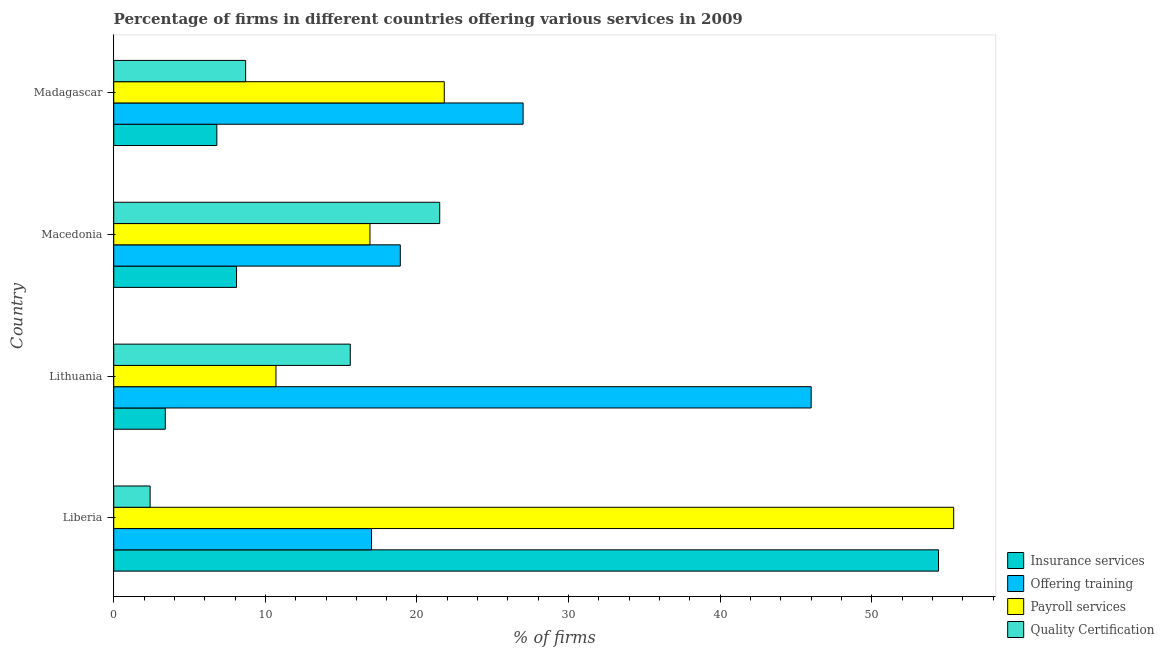How many different coloured bars are there?
Offer a very short reply. 4. How many bars are there on the 3rd tick from the top?
Offer a very short reply. 4. What is the label of the 1st group of bars from the top?
Ensure brevity in your answer.  Madagascar. In how many cases, is the number of bars for a given country not equal to the number of legend labels?
Make the answer very short. 0. Across all countries, what is the maximum percentage of firms offering payroll services?
Provide a succinct answer. 55.4. In which country was the percentage of firms offering payroll services maximum?
Ensure brevity in your answer.  Liberia. In which country was the percentage of firms offering insurance services minimum?
Provide a short and direct response. Lithuania. What is the total percentage of firms offering payroll services in the graph?
Your response must be concise. 104.8. What is the difference between the percentage of firms offering payroll services in Madagascar and the percentage of firms offering quality certification in Macedonia?
Ensure brevity in your answer.  0.3. What is the average percentage of firms offering insurance services per country?
Your answer should be very brief. 18.18. What is the difference between the percentage of firms offering payroll services and percentage of firms offering training in Liberia?
Offer a terse response. 38.4. What is the ratio of the percentage of firms offering payroll services in Liberia to that in Macedonia?
Your answer should be compact. 3.28. Is the difference between the percentage of firms offering quality certification in Macedonia and Madagascar greater than the difference between the percentage of firms offering payroll services in Macedonia and Madagascar?
Your response must be concise. Yes. What is the difference between the highest and the second highest percentage of firms offering payroll services?
Offer a terse response. 33.6. What is the difference between the highest and the lowest percentage of firms offering training?
Offer a terse response. 29. In how many countries, is the percentage of firms offering payroll services greater than the average percentage of firms offering payroll services taken over all countries?
Ensure brevity in your answer.  1. Is it the case that in every country, the sum of the percentage of firms offering insurance services and percentage of firms offering payroll services is greater than the sum of percentage of firms offering training and percentage of firms offering quality certification?
Provide a short and direct response. No. What does the 1st bar from the top in Macedonia represents?
Your response must be concise. Quality Certification. What does the 3rd bar from the bottom in Madagascar represents?
Your response must be concise. Payroll services. Are all the bars in the graph horizontal?
Provide a succinct answer. Yes. What is the difference between two consecutive major ticks on the X-axis?
Provide a succinct answer. 10. Are the values on the major ticks of X-axis written in scientific E-notation?
Your answer should be very brief. No. Where does the legend appear in the graph?
Your response must be concise. Bottom right. How are the legend labels stacked?
Provide a short and direct response. Vertical. What is the title of the graph?
Offer a terse response. Percentage of firms in different countries offering various services in 2009. What is the label or title of the X-axis?
Provide a succinct answer. % of firms. What is the % of firms in Insurance services in Liberia?
Your answer should be very brief. 54.4. What is the % of firms in Payroll services in Liberia?
Provide a short and direct response. 55.4. What is the % of firms of Offering training in Lithuania?
Ensure brevity in your answer.  46. What is the % of firms of Quality Certification in Lithuania?
Your answer should be very brief. 15.6. What is the % of firms of Offering training in Macedonia?
Your answer should be compact. 18.9. What is the % of firms of Payroll services in Macedonia?
Your answer should be very brief. 16.9. What is the % of firms in Quality Certification in Macedonia?
Your answer should be compact. 21.5. What is the % of firms in Insurance services in Madagascar?
Ensure brevity in your answer.  6.8. What is the % of firms in Payroll services in Madagascar?
Provide a succinct answer. 21.8. Across all countries, what is the maximum % of firms of Insurance services?
Give a very brief answer. 54.4. Across all countries, what is the maximum % of firms in Payroll services?
Provide a succinct answer. 55.4. Across all countries, what is the maximum % of firms of Quality Certification?
Your response must be concise. 21.5. Across all countries, what is the minimum % of firms of Offering training?
Your response must be concise. 17. What is the total % of firms in Insurance services in the graph?
Make the answer very short. 72.7. What is the total % of firms in Offering training in the graph?
Your response must be concise. 108.9. What is the total % of firms in Payroll services in the graph?
Offer a terse response. 104.8. What is the total % of firms in Quality Certification in the graph?
Keep it short and to the point. 48.2. What is the difference between the % of firms in Insurance services in Liberia and that in Lithuania?
Give a very brief answer. 51. What is the difference between the % of firms of Payroll services in Liberia and that in Lithuania?
Provide a short and direct response. 44.7. What is the difference between the % of firms of Insurance services in Liberia and that in Macedonia?
Ensure brevity in your answer.  46.3. What is the difference between the % of firms in Payroll services in Liberia and that in Macedonia?
Offer a terse response. 38.5. What is the difference between the % of firms in Quality Certification in Liberia and that in Macedonia?
Keep it short and to the point. -19.1. What is the difference between the % of firms of Insurance services in Liberia and that in Madagascar?
Your answer should be very brief. 47.6. What is the difference between the % of firms of Offering training in Liberia and that in Madagascar?
Keep it short and to the point. -10. What is the difference between the % of firms of Payroll services in Liberia and that in Madagascar?
Your answer should be compact. 33.6. What is the difference between the % of firms of Insurance services in Lithuania and that in Macedonia?
Provide a succinct answer. -4.7. What is the difference between the % of firms in Offering training in Lithuania and that in Macedonia?
Give a very brief answer. 27.1. What is the difference between the % of firms of Payroll services in Lithuania and that in Macedonia?
Offer a terse response. -6.2. What is the difference between the % of firms of Insurance services in Lithuania and that in Madagascar?
Give a very brief answer. -3.4. What is the difference between the % of firms in Offering training in Lithuania and that in Madagascar?
Your response must be concise. 19. What is the difference between the % of firms of Insurance services in Macedonia and that in Madagascar?
Your answer should be very brief. 1.3. What is the difference between the % of firms in Offering training in Macedonia and that in Madagascar?
Keep it short and to the point. -8.1. What is the difference between the % of firms of Payroll services in Macedonia and that in Madagascar?
Your response must be concise. -4.9. What is the difference between the % of firms of Insurance services in Liberia and the % of firms of Offering training in Lithuania?
Keep it short and to the point. 8.4. What is the difference between the % of firms of Insurance services in Liberia and the % of firms of Payroll services in Lithuania?
Your response must be concise. 43.7. What is the difference between the % of firms in Insurance services in Liberia and the % of firms in Quality Certification in Lithuania?
Your answer should be very brief. 38.8. What is the difference between the % of firms of Offering training in Liberia and the % of firms of Payroll services in Lithuania?
Offer a very short reply. 6.3. What is the difference between the % of firms in Offering training in Liberia and the % of firms in Quality Certification in Lithuania?
Give a very brief answer. 1.4. What is the difference between the % of firms in Payroll services in Liberia and the % of firms in Quality Certification in Lithuania?
Provide a short and direct response. 39.8. What is the difference between the % of firms of Insurance services in Liberia and the % of firms of Offering training in Macedonia?
Keep it short and to the point. 35.5. What is the difference between the % of firms in Insurance services in Liberia and the % of firms in Payroll services in Macedonia?
Offer a very short reply. 37.5. What is the difference between the % of firms of Insurance services in Liberia and the % of firms of Quality Certification in Macedonia?
Offer a very short reply. 32.9. What is the difference between the % of firms in Offering training in Liberia and the % of firms in Payroll services in Macedonia?
Your answer should be very brief. 0.1. What is the difference between the % of firms of Offering training in Liberia and the % of firms of Quality Certification in Macedonia?
Your answer should be compact. -4.5. What is the difference between the % of firms of Payroll services in Liberia and the % of firms of Quality Certification in Macedonia?
Ensure brevity in your answer.  33.9. What is the difference between the % of firms of Insurance services in Liberia and the % of firms of Offering training in Madagascar?
Your answer should be very brief. 27.4. What is the difference between the % of firms in Insurance services in Liberia and the % of firms in Payroll services in Madagascar?
Give a very brief answer. 32.6. What is the difference between the % of firms in Insurance services in Liberia and the % of firms in Quality Certification in Madagascar?
Your answer should be very brief. 45.7. What is the difference between the % of firms of Offering training in Liberia and the % of firms of Quality Certification in Madagascar?
Provide a short and direct response. 8.3. What is the difference between the % of firms in Payroll services in Liberia and the % of firms in Quality Certification in Madagascar?
Offer a terse response. 46.7. What is the difference between the % of firms in Insurance services in Lithuania and the % of firms in Offering training in Macedonia?
Offer a very short reply. -15.5. What is the difference between the % of firms in Insurance services in Lithuania and the % of firms in Payroll services in Macedonia?
Your answer should be compact. -13.5. What is the difference between the % of firms of Insurance services in Lithuania and the % of firms of Quality Certification in Macedonia?
Provide a short and direct response. -18.1. What is the difference between the % of firms of Offering training in Lithuania and the % of firms of Payroll services in Macedonia?
Give a very brief answer. 29.1. What is the difference between the % of firms in Offering training in Lithuania and the % of firms in Quality Certification in Macedonia?
Ensure brevity in your answer.  24.5. What is the difference between the % of firms of Payroll services in Lithuania and the % of firms of Quality Certification in Macedonia?
Your response must be concise. -10.8. What is the difference between the % of firms in Insurance services in Lithuania and the % of firms in Offering training in Madagascar?
Give a very brief answer. -23.6. What is the difference between the % of firms in Insurance services in Lithuania and the % of firms in Payroll services in Madagascar?
Provide a short and direct response. -18.4. What is the difference between the % of firms of Offering training in Lithuania and the % of firms of Payroll services in Madagascar?
Offer a terse response. 24.2. What is the difference between the % of firms in Offering training in Lithuania and the % of firms in Quality Certification in Madagascar?
Offer a very short reply. 37.3. What is the difference between the % of firms of Insurance services in Macedonia and the % of firms of Offering training in Madagascar?
Ensure brevity in your answer.  -18.9. What is the difference between the % of firms in Insurance services in Macedonia and the % of firms in Payroll services in Madagascar?
Your answer should be compact. -13.7. What is the difference between the % of firms of Insurance services in Macedonia and the % of firms of Quality Certification in Madagascar?
Make the answer very short. -0.6. What is the difference between the % of firms of Offering training in Macedonia and the % of firms of Payroll services in Madagascar?
Your answer should be compact. -2.9. What is the difference between the % of firms of Payroll services in Macedonia and the % of firms of Quality Certification in Madagascar?
Give a very brief answer. 8.2. What is the average % of firms in Insurance services per country?
Offer a terse response. 18.18. What is the average % of firms of Offering training per country?
Your answer should be compact. 27.23. What is the average % of firms of Payroll services per country?
Your answer should be very brief. 26.2. What is the average % of firms of Quality Certification per country?
Ensure brevity in your answer.  12.05. What is the difference between the % of firms of Insurance services and % of firms of Offering training in Liberia?
Offer a very short reply. 37.4. What is the difference between the % of firms of Insurance services and % of firms of Quality Certification in Liberia?
Provide a short and direct response. 52. What is the difference between the % of firms of Offering training and % of firms of Payroll services in Liberia?
Make the answer very short. -38.4. What is the difference between the % of firms of Insurance services and % of firms of Offering training in Lithuania?
Your answer should be very brief. -42.6. What is the difference between the % of firms in Insurance services and % of firms in Payroll services in Lithuania?
Offer a terse response. -7.3. What is the difference between the % of firms of Offering training and % of firms of Payroll services in Lithuania?
Your answer should be compact. 35.3. What is the difference between the % of firms in Offering training and % of firms in Quality Certification in Lithuania?
Ensure brevity in your answer.  30.4. What is the difference between the % of firms in Payroll services and % of firms in Quality Certification in Lithuania?
Ensure brevity in your answer.  -4.9. What is the difference between the % of firms of Insurance services and % of firms of Offering training in Macedonia?
Offer a terse response. -10.8. What is the difference between the % of firms in Offering training and % of firms in Payroll services in Macedonia?
Provide a short and direct response. 2. What is the difference between the % of firms of Payroll services and % of firms of Quality Certification in Macedonia?
Make the answer very short. -4.6. What is the difference between the % of firms in Insurance services and % of firms in Offering training in Madagascar?
Offer a very short reply. -20.2. What is the ratio of the % of firms in Offering training in Liberia to that in Lithuania?
Give a very brief answer. 0.37. What is the ratio of the % of firms in Payroll services in Liberia to that in Lithuania?
Offer a very short reply. 5.18. What is the ratio of the % of firms of Quality Certification in Liberia to that in Lithuania?
Provide a succinct answer. 0.15. What is the ratio of the % of firms in Insurance services in Liberia to that in Macedonia?
Give a very brief answer. 6.72. What is the ratio of the % of firms of Offering training in Liberia to that in Macedonia?
Keep it short and to the point. 0.9. What is the ratio of the % of firms of Payroll services in Liberia to that in Macedonia?
Your response must be concise. 3.28. What is the ratio of the % of firms in Quality Certification in Liberia to that in Macedonia?
Provide a short and direct response. 0.11. What is the ratio of the % of firms of Offering training in Liberia to that in Madagascar?
Give a very brief answer. 0.63. What is the ratio of the % of firms in Payroll services in Liberia to that in Madagascar?
Offer a very short reply. 2.54. What is the ratio of the % of firms in Quality Certification in Liberia to that in Madagascar?
Offer a terse response. 0.28. What is the ratio of the % of firms in Insurance services in Lithuania to that in Macedonia?
Keep it short and to the point. 0.42. What is the ratio of the % of firms in Offering training in Lithuania to that in Macedonia?
Keep it short and to the point. 2.43. What is the ratio of the % of firms of Payroll services in Lithuania to that in Macedonia?
Provide a succinct answer. 0.63. What is the ratio of the % of firms in Quality Certification in Lithuania to that in Macedonia?
Ensure brevity in your answer.  0.73. What is the ratio of the % of firms in Insurance services in Lithuania to that in Madagascar?
Provide a succinct answer. 0.5. What is the ratio of the % of firms in Offering training in Lithuania to that in Madagascar?
Your answer should be very brief. 1.7. What is the ratio of the % of firms in Payroll services in Lithuania to that in Madagascar?
Provide a short and direct response. 0.49. What is the ratio of the % of firms of Quality Certification in Lithuania to that in Madagascar?
Your response must be concise. 1.79. What is the ratio of the % of firms of Insurance services in Macedonia to that in Madagascar?
Your answer should be very brief. 1.19. What is the ratio of the % of firms in Payroll services in Macedonia to that in Madagascar?
Provide a succinct answer. 0.78. What is the ratio of the % of firms in Quality Certification in Macedonia to that in Madagascar?
Give a very brief answer. 2.47. What is the difference between the highest and the second highest % of firms in Insurance services?
Give a very brief answer. 46.3. What is the difference between the highest and the second highest % of firms of Offering training?
Offer a very short reply. 19. What is the difference between the highest and the second highest % of firms in Payroll services?
Your answer should be very brief. 33.6. What is the difference between the highest and the second highest % of firms of Quality Certification?
Provide a short and direct response. 5.9. What is the difference between the highest and the lowest % of firms in Insurance services?
Make the answer very short. 51. What is the difference between the highest and the lowest % of firms of Payroll services?
Offer a very short reply. 44.7. 